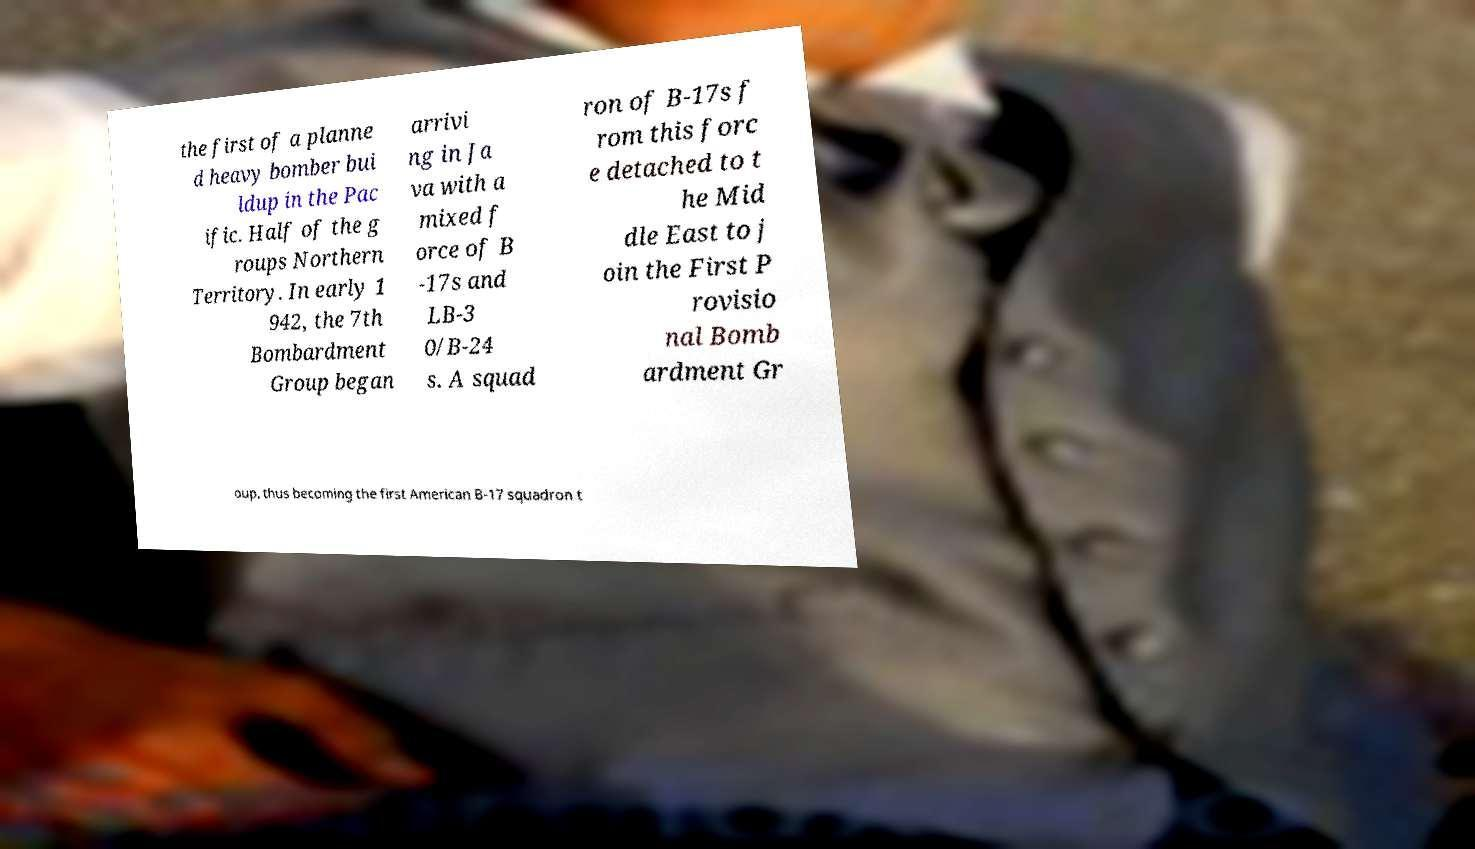Please read and relay the text visible in this image. What does it say? the first of a planne d heavy bomber bui ldup in the Pac ific. Half of the g roups Northern Territory. In early 1 942, the 7th Bombardment Group began arrivi ng in Ja va with a mixed f orce of B -17s and LB-3 0/B-24 s. A squad ron of B-17s f rom this forc e detached to t he Mid dle East to j oin the First P rovisio nal Bomb ardment Gr oup, thus becoming the first American B-17 squadron t 